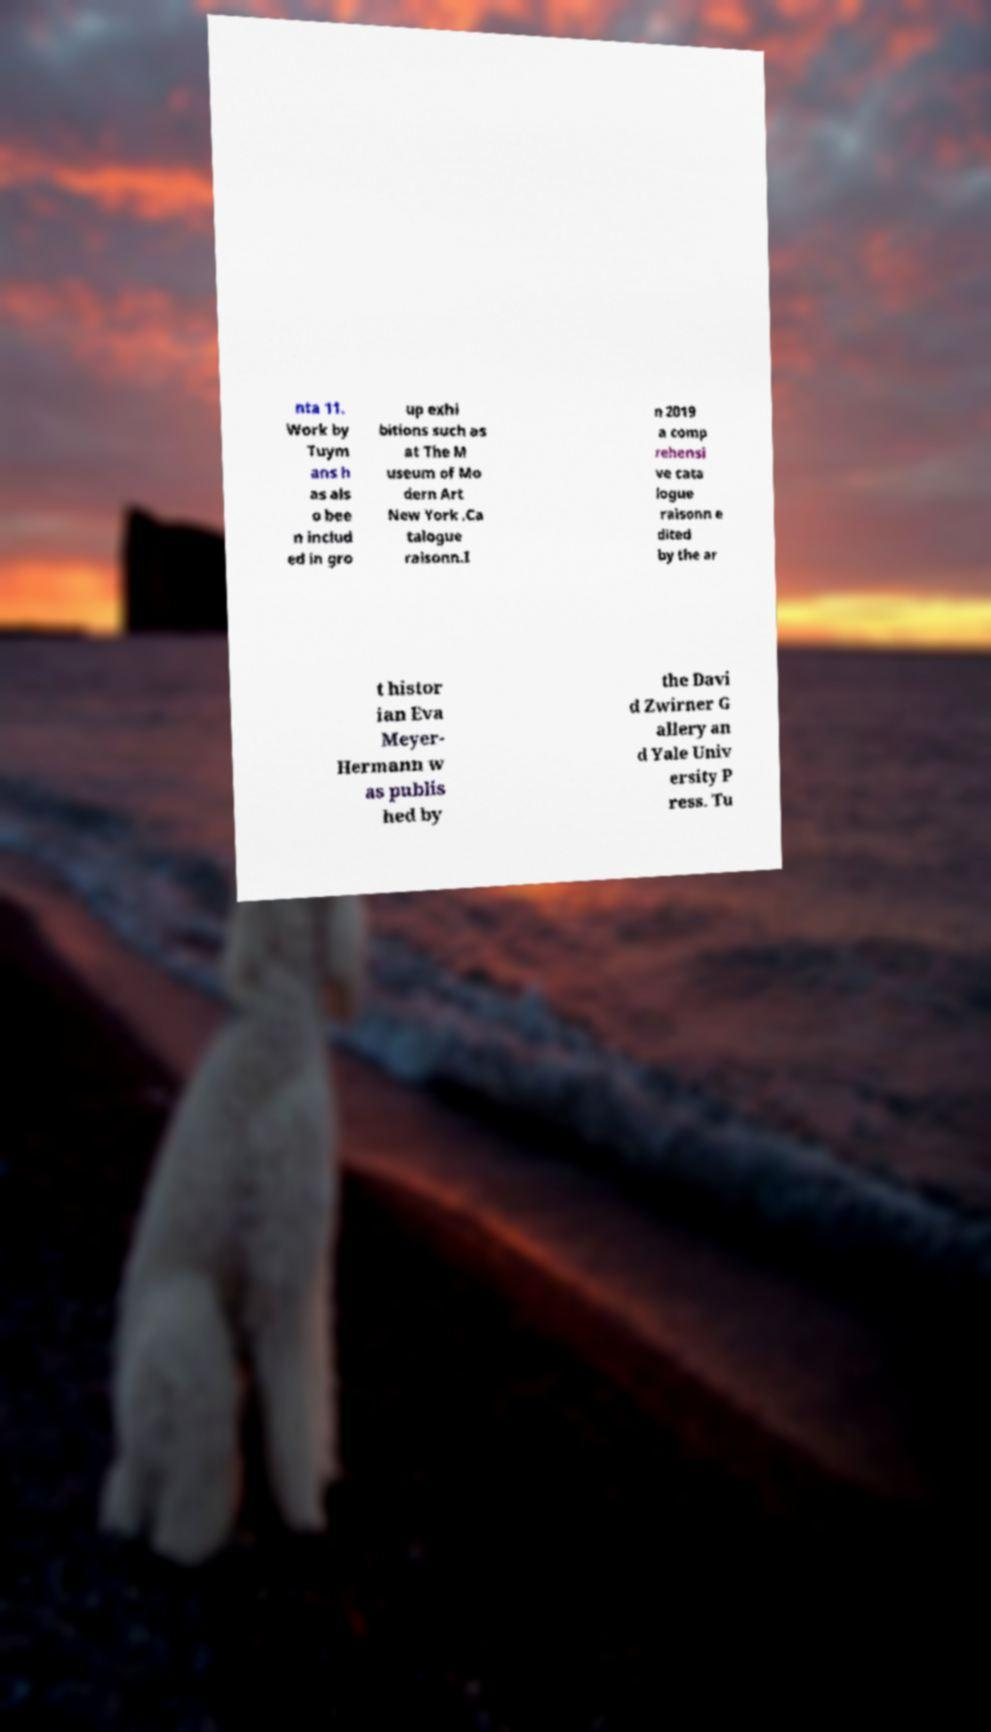Please identify and transcribe the text found in this image. nta 11. Work by Tuym ans h as als o bee n includ ed in gro up exhi bitions such as at The M useum of Mo dern Art New York .Ca talogue raisonn.I n 2019 a comp rehensi ve cata logue raisonn e dited by the ar t histor ian Eva Meyer- Hermann w as publis hed by the Davi d Zwirner G allery an d Yale Univ ersity P ress. Tu 